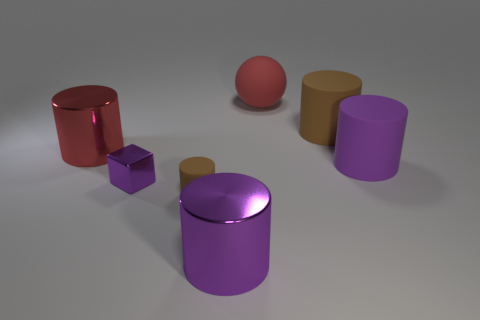Subtract 1 cylinders. How many cylinders are left? 4 Subtract all red cylinders. How many cylinders are left? 4 Subtract all small brown matte cylinders. How many cylinders are left? 4 Subtract all yellow cylinders. Subtract all purple spheres. How many cylinders are left? 5 Add 1 big red cylinders. How many objects exist? 8 Subtract all cylinders. How many objects are left? 2 Add 7 yellow cylinders. How many yellow cylinders exist? 7 Subtract 0 gray balls. How many objects are left? 7 Subtract all tiny cyan matte balls. Subtract all purple rubber objects. How many objects are left? 6 Add 4 matte spheres. How many matte spheres are left? 5 